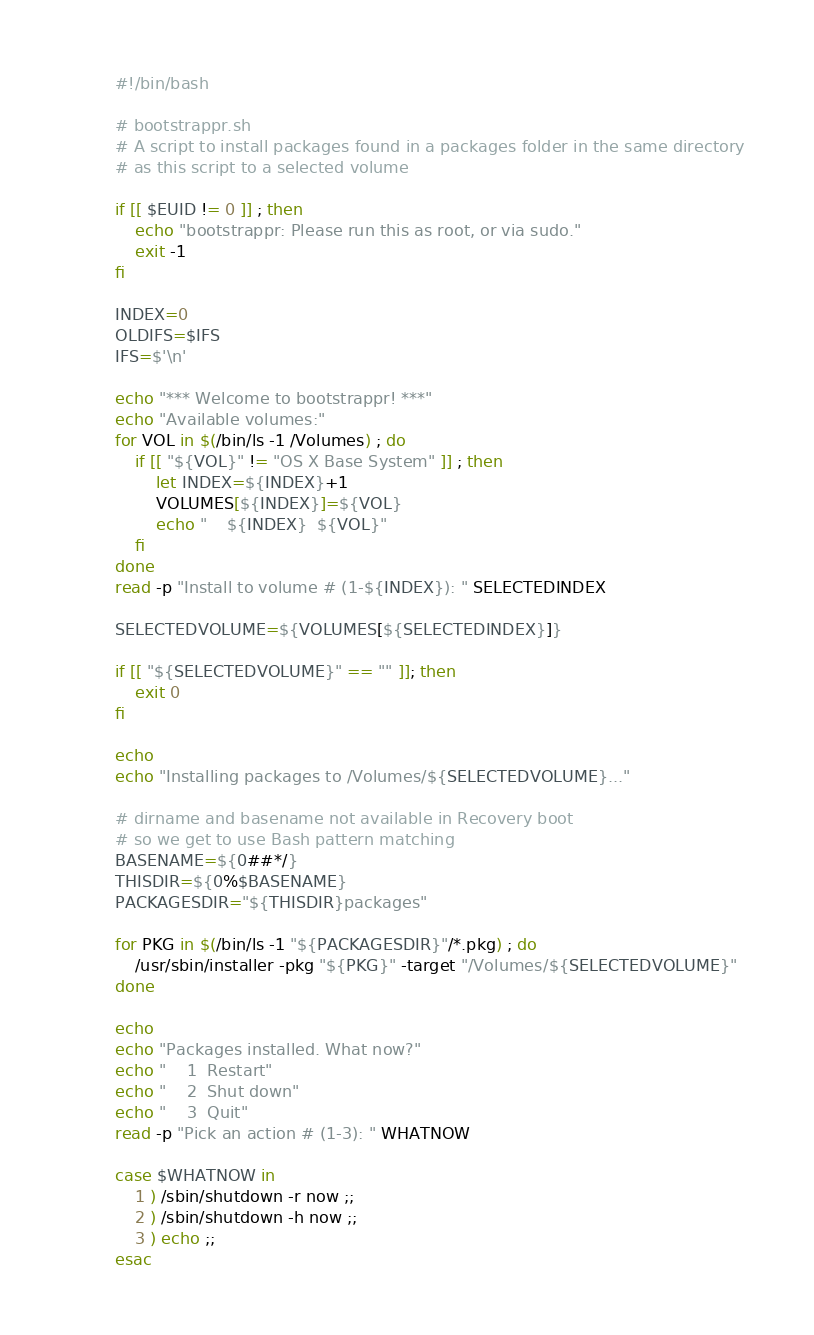Convert code to text. <code><loc_0><loc_0><loc_500><loc_500><_Bash_>#!/bin/bash

# bootstrappr.sh
# A script to install packages found in a packages folder in the same directory
# as this script to a selected volume

if [[ $EUID != 0 ]] ; then
    echo "bootstrappr: Please run this as root, or via sudo."
    exit -1
fi

INDEX=0
OLDIFS=$IFS
IFS=$'\n'

echo "*** Welcome to bootstrappr! ***"
echo "Available volumes:"
for VOL in $(/bin/ls -1 /Volumes) ; do
    if [[ "${VOL}" != "OS X Base System" ]] ; then
        let INDEX=${INDEX}+1
        VOLUMES[${INDEX}]=${VOL}
        echo "    ${INDEX}  ${VOL}"
    fi
done
read -p "Install to volume # (1-${INDEX}): " SELECTEDINDEX

SELECTEDVOLUME=${VOLUMES[${SELECTEDINDEX}]}

if [[ "${SELECTEDVOLUME}" == "" ]]; then
    exit 0
fi

echo
echo "Installing packages to /Volumes/${SELECTEDVOLUME}..."

# dirname and basename not available in Recovery boot
# so we get to use Bash pattern matching
BASENAME=${0##*/}
THISDIR=${0%$BASENAME}
PACKAGESDIR="${THISDIR}packages"

for PKG in $(/bin/ls -1 "${PACKAGESDIR}"/*.pkg) ; do
    /usr/sbin/installer -pkg "${PKG}" -target "/Volumes/${SELECTEDVOLUME}"
done

echo
echo "Packages installed. What now?"
echo "    1  Restart"
echo "    2  Shut down"
echo "    3  Quit"
read -p "Pick an action # (1-3): " WHATNOW

case $WHATNOW in
    1 ) /sbin/shutdown -r now ;;
    2 ) /sbin/shutdown -h now ;;
    3 ) echo ;;
esac
</code> 